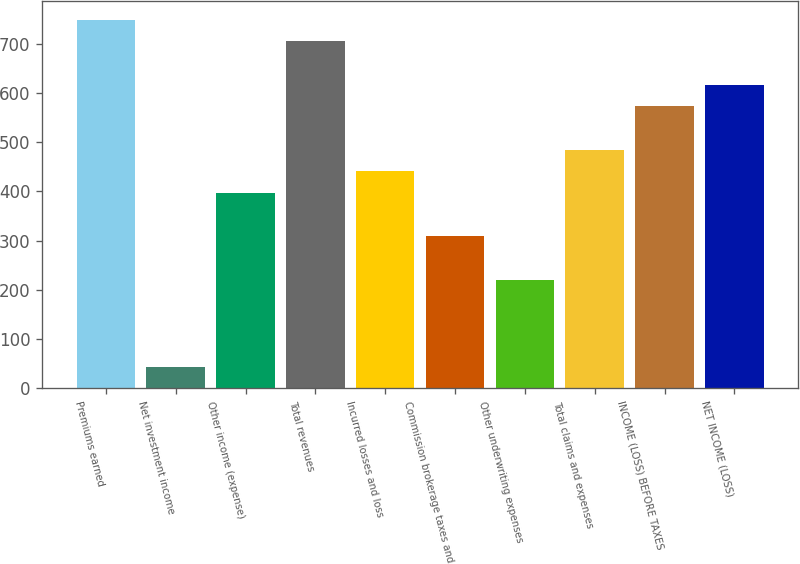<chart> <loc_0><loc_0><loc_500><loc_500><bar_chart><fcel>Premiums earned<fcel>Net investment income<fcel>Other income (expense)<fcel>Total revenues<fcel>Incurred losses and loss<fcel>Commission brokerage taxes and<fcel>Other underwriting expenses<fcel>Total claims and expenses<fcel>INCOME (LOSS) BEFORE TAXES<fcel>NET INCOME (LOSS)<nl><fcel>748.88<fcel>44.24<fcel>396.56<fcel>704.84<fcel>440.6<fcel>308.48<fcel>220.4<fcel>484.64<fcel>572.72<fcel>616.76<nl></chart> 